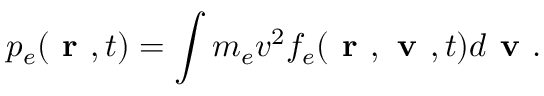<formula> <loc_0><loc_0><loc_500><loc_500>p _ { e } ( r , t ) = \int m _ { e } v ^ { 2 } f _ { e } ( r , v , t ) d v .</formula> 